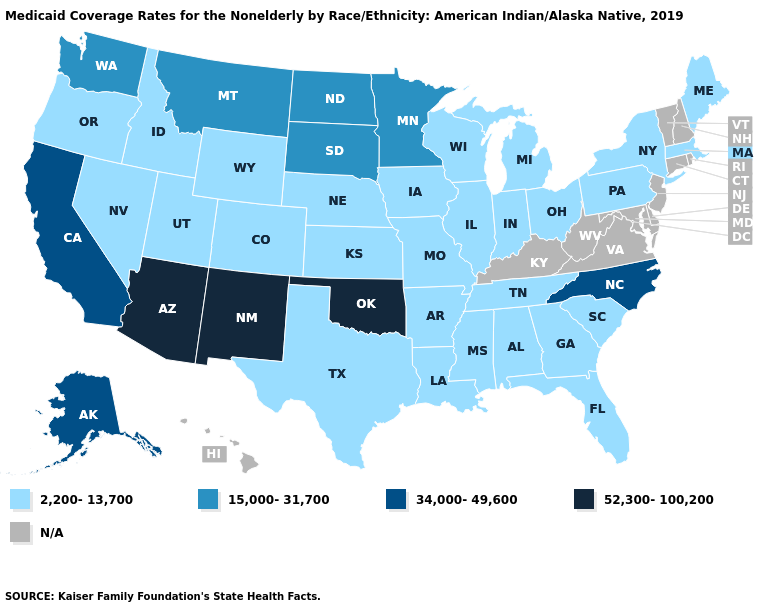How many symbols are there in the legend?
Be succinct. 5. Among the states that border Georgia , which have the lowest value?
Answer briefly. Alabama, Florida, South Carolina, Tennessee. Name the states that have a value in the range 34,000-49,600?
Short answer required. Alaska, California, North Carolina. Does the map have missing data?
Short answer required. Yes. Does Nebraska have the lowest value in the MidWest?
Quick response, please. Yes. What is the highest value in the USA?
Quick response, please. 52,300-100,200. Which states hav the highest value in the Northeast?
Be succinct. Maine, Massachusetts, New York, Pennsylvania. Name the states that have a value in the range 15,000-31,700?
Answer briefly. Minnesota, Montana, North Dakota, South Dakota, Washington. Does Oregon have the lowest value in the USA?
Write a very short answer. Yes. What is the highest value in the MidWest ?
Give a very brief answer. 15,000-31,700. Among the states that border California , does Arizona have the lowest value?
Keep it brief. No. What is the value of Massachusetts?
Short answer required. 2,200-13,700. Does the map have missing data?
Write a very short answer. Yes. Name the states that have a value in the range 2,200-13,700?
Answer briefly. Alabama, Arkansas, Colorado, Florida, Georgia, Idaho, Illinois, Indiana, Iowa, Kansas, Louisiana, Maine, Massachusetts, Michigan, Mississippi, Missouri, Nebraska, Nevada, New York, Ohio, Oregon, Pennsylvania, South Carolina, Tennessee, Texas, Utah, Wisconsin, Wyoming. 